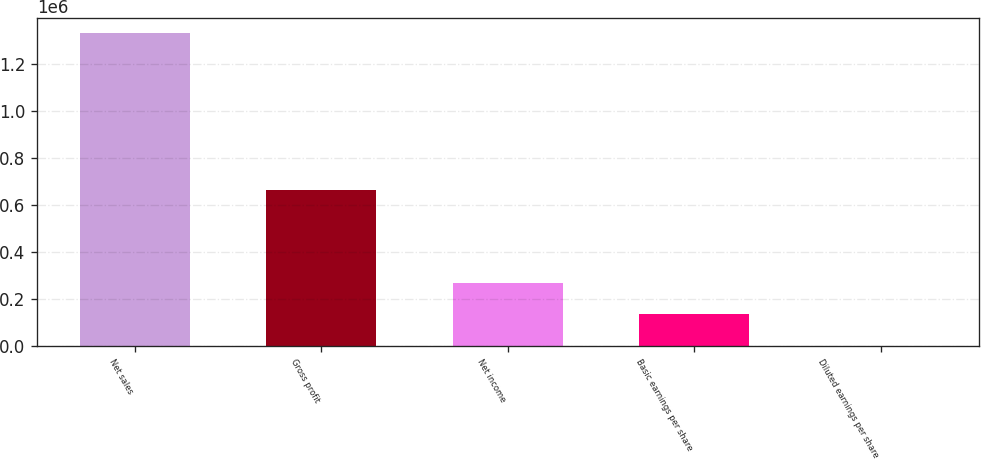Convert chart to OTSL. <chart><loc_0><loc_0><loc_500><loc_500><bar_chart><fcel>Net sales<fcel>Gross profit<fcel>Net income<fcel>Basic earnings per share<fcel>Diluted earnings per share<nl><fcel>1.3292e+06<fcel>663155<fcel>265841<fcel>132921<fcel>0.88<nl></chart> 